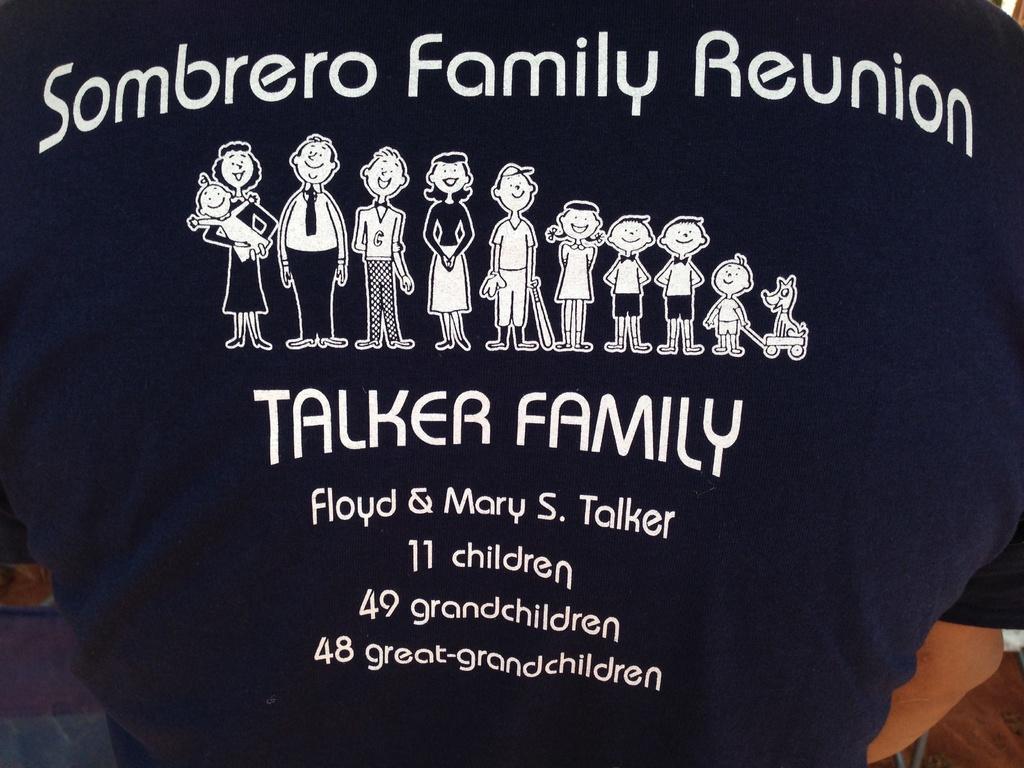Describe this image in one or two sentences. In this image in the center there is a person standing wearing a black t-shirt and there is some text on the t-shirt with images. 